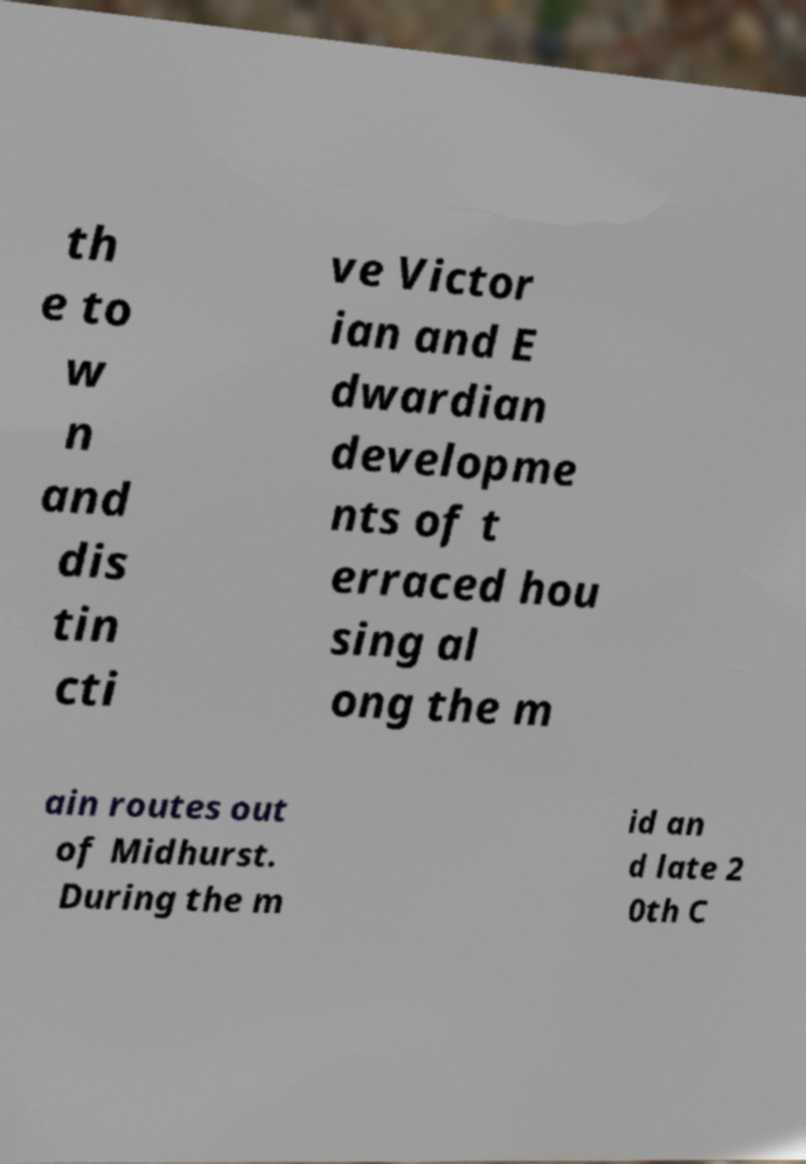Could you extract and type out the text from this image? th e to w n and dis tin cti ve Victor ian and E dwardian developme nts of t erraced hou sing al ong the m ain routes out of Midhurst. During the m id an d late 2 0th C 